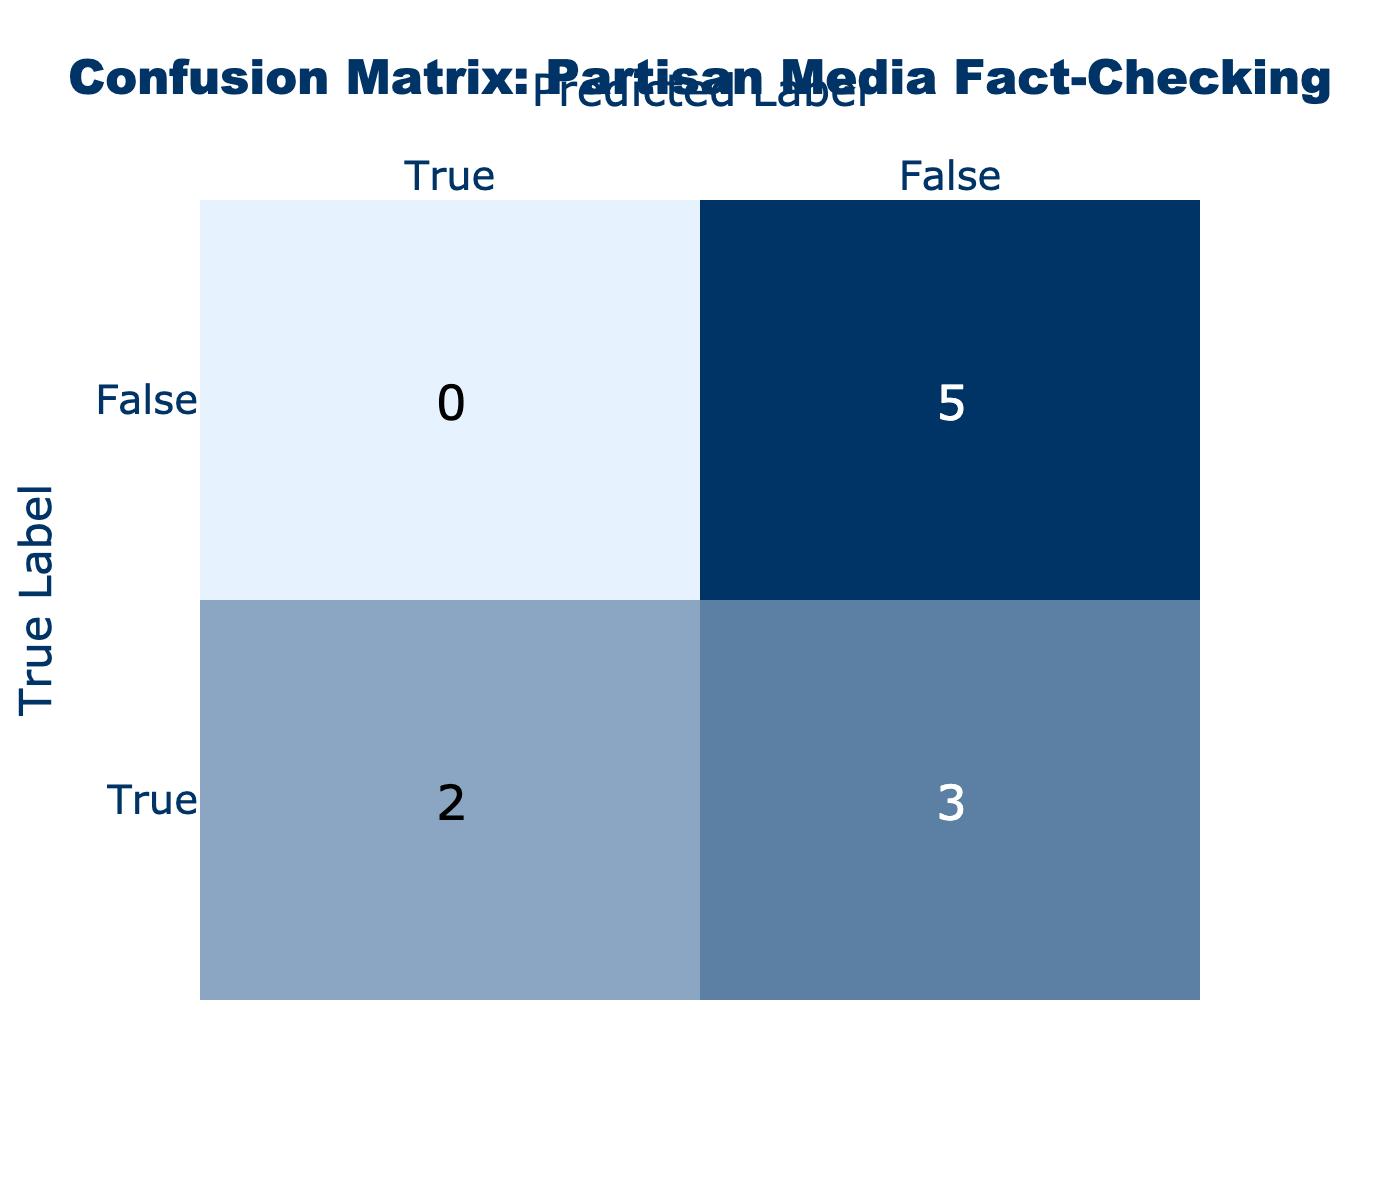What is the total number of claims labeled as True? The claims labeled as True are "Climate change is causing more extreme weather events," "Tax cuts only benefit the wealthy," "Voter ID laws disproportionately impact minorities," "Freedom of press is threatened in current administration," and "Gun violence can be mitigated through stricter laws." Counting these, there are 5 claims labeled as True.
Answer: 5 How many claims did Fox News get wrong? Fox News predicted "Immigration crime rates have doubled in the last year" as True, while it is False. Since this is the only claim from Fox News, they got 1 claim wrong.
Answer: 1 What is the difference between the number of True and False predicted labels? The table lists 5 True predictions (from CNN, MSNBC, HuffPost, The Guardian, and The Atlantic) and 4 False predictions (from Breitbart, Newsmax, and others). The difference is calculated as 5 - 4 = 1.
Answer: 1 Did CNN accurately predict the label for its claim? CNN's claim "Climate change is causing more extreme weather events" is labeled True, and its prediction matches this label. Therefore, CNN accurately predicted the label for its claim.
Answer: Yes Which media source had the highest number of True predictions? The True predictions come from multiple sources. Here are the sources and their counts: CNN (1), MSNBC (1), HuffPost (1), The Guardian (1), and The Atlantic (1), totaling 5 from these sources. Since no one source is listed more than once, they are all tied.
Answer: All tied with 1 each What is the total number of claims made by partisan media sources? The total number of claims can be counted by looking at each row in the data. There are 10 claims listed in total, each corresponding to a media source.
Answer: 10 How many claims predicted as True were actually False? From the data, only the claim from Fox News is counted where True was predicted, but it is actually False. Therefore, there is 1 claim that meets this criterion.
Answer: 1 Which media source had a perfect prediction score? A perfect prediction score means all claims were correctly labeled. The sources that did not incorrectly predict any claims, specifically Breitbart and Newsmax, are accurately in line with expectations. Therefore, they had perfect prediction scores.
Answer: Breitbart and Newsmax 